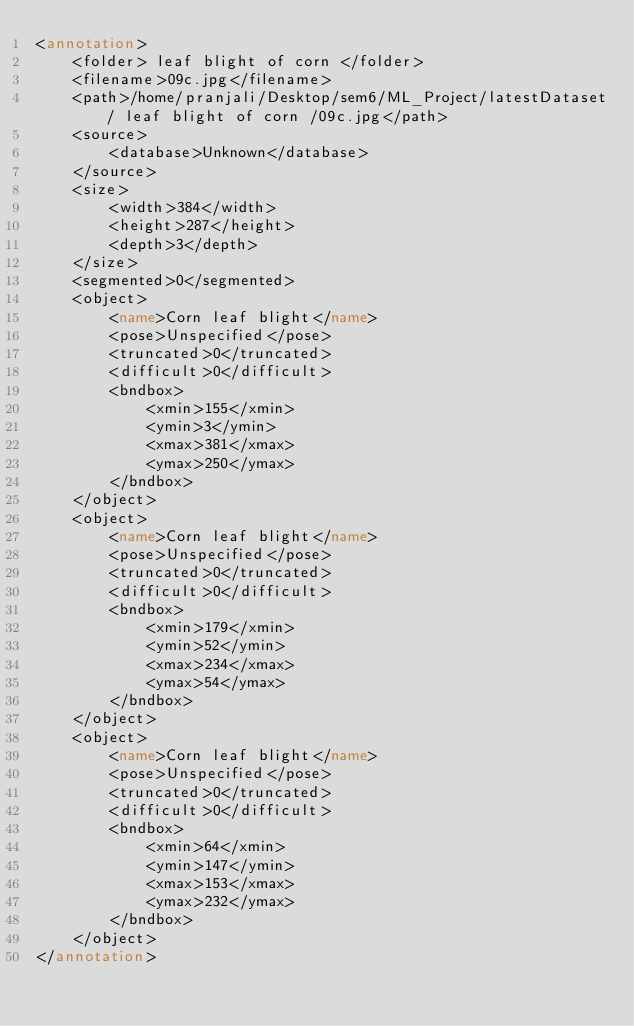Convert code to text. <code><loc_0><loc_0><loc_500><loc_500><_XML_><annotation>
	<folder> leaf blight of corn </folder>
	<filename>09c.jpg</filename>
	<path>/home/pranjali/Desktop/sem6/ML_Project/latestDataset/ leaf blight of corn /09c.jpg</path>
	<source>
		<database>Unknown</database>
	</source>
	<size>
		<width>384</width>
		<height>287</height>
		<depth>3</depth>
	</size>
	<segmented>0</segmented>
	<object>
		<name>Corn leaf blight</name>
		<pose>Unspecified</pose>
		<truncated>0</truncated>
		<difficult>0</difficult>
		<bndbox>
			<xmin>155</xmin>
			<ymin>3</ymin>
			<xmax>381</xmax>
			<ymax>250</ymax>
		</bndbox>
	</object>
	<object>
		<name>Corn leaf blight</name>
		<pose>Unspecified</pose>
		<truncated>0</truncated>
		<difficult>0</difficult>
		<bndbox>
			<xmin>179</xmin>
			<ymin>52</ymin>
			<xmax>234</xmax>
			<ymax>54</ymax>
		</bndbox>
	</object>
	<object>
		<name>Corn leaf blight</name>
		<pose>Unspecified</pose>
		<truncated>0</truncated>
		<difficult>0</difficult>
		<bndbox>
			<xmin>64</xmin>
			<ymin>147</ymin>
			<xmax>153</xmax>
			<ymax>232</ymax>
		</bndbox>
	</object>
</annotation>
</code> 